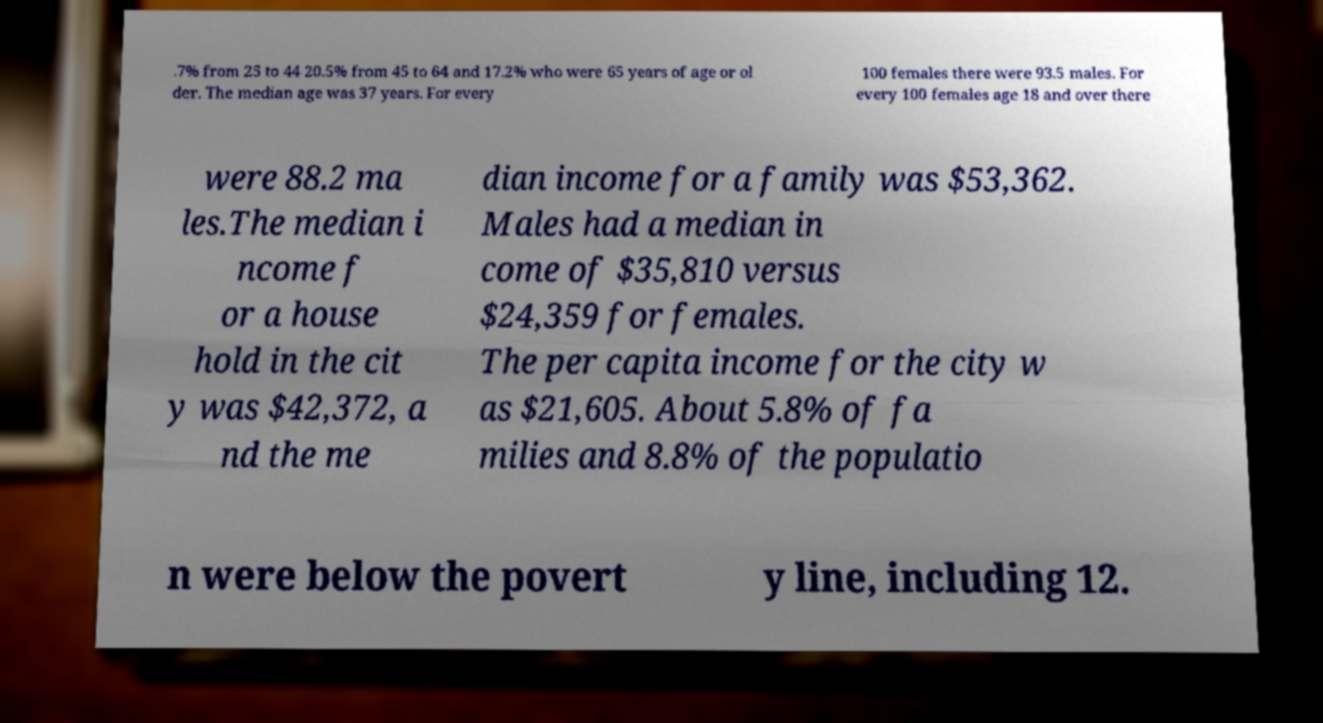I need the written content from this picture converted into text. Can you do that? .7% from 25 to 44 20.5% from 45 to 64 and 17.2% who were 65 years of age or ol der. The median age was 37 years. For every 100 females there were 93.5 males. For every 100 females age 18 and over there were 88.2 ma les.The median i ncome f or a house hold in the cit y was $42,372, a nd the me dian income for a family was $53,362. Males had a median in come of $35,810 versus $24,359 for females. The per capita income for the city w as $21,605. About 5.8% of fa milies and 8.8% of the populatio n were below the povert y line, including 12. 